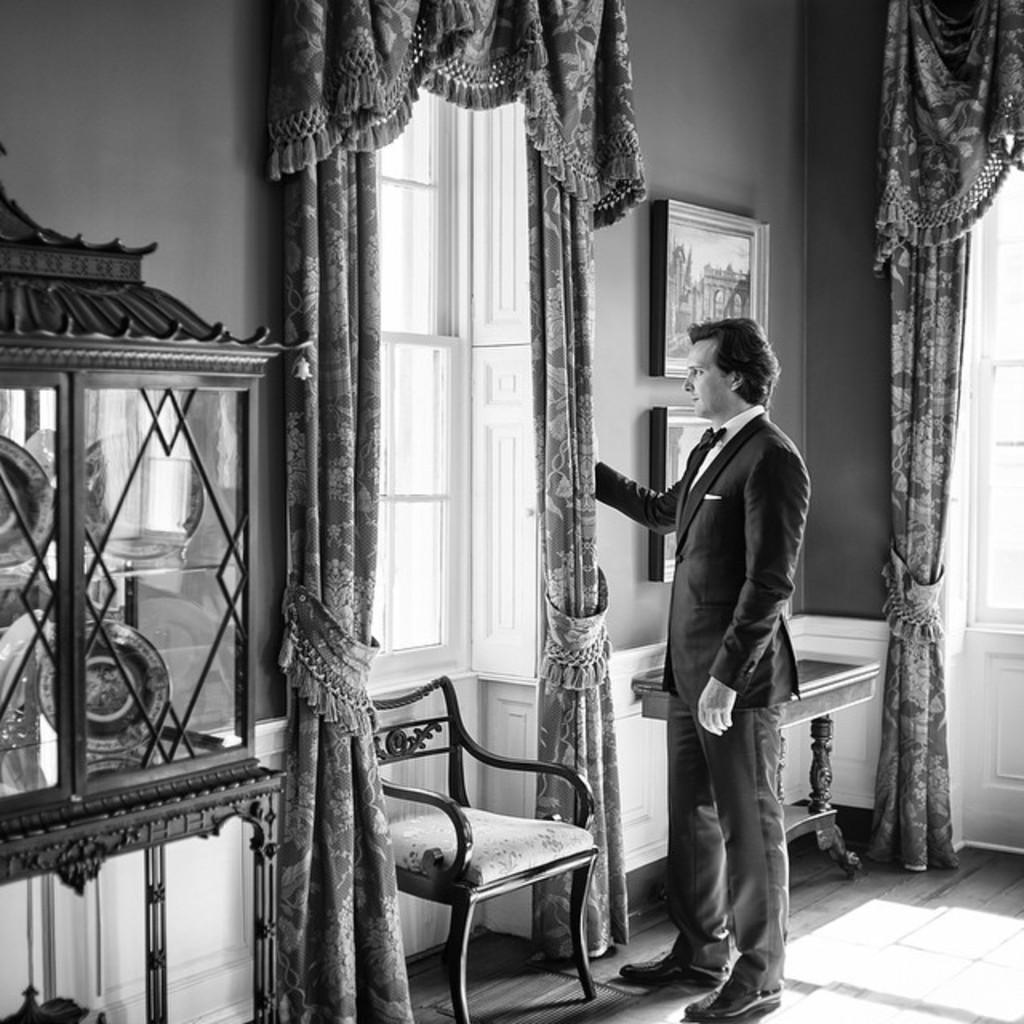What is the main subject of the image? There is a man standing in the image. Where is the man positioned in relation to the window? The man is standing in front of a window. What type of window treatment is visible in the image? There are curtains hanging in the image. Can you describe any other objects or features in the image? There is a photo frame on the wall in the image. What type of potato is the man holding in the image? There is no potato present in the image; the man is not holding anything. 